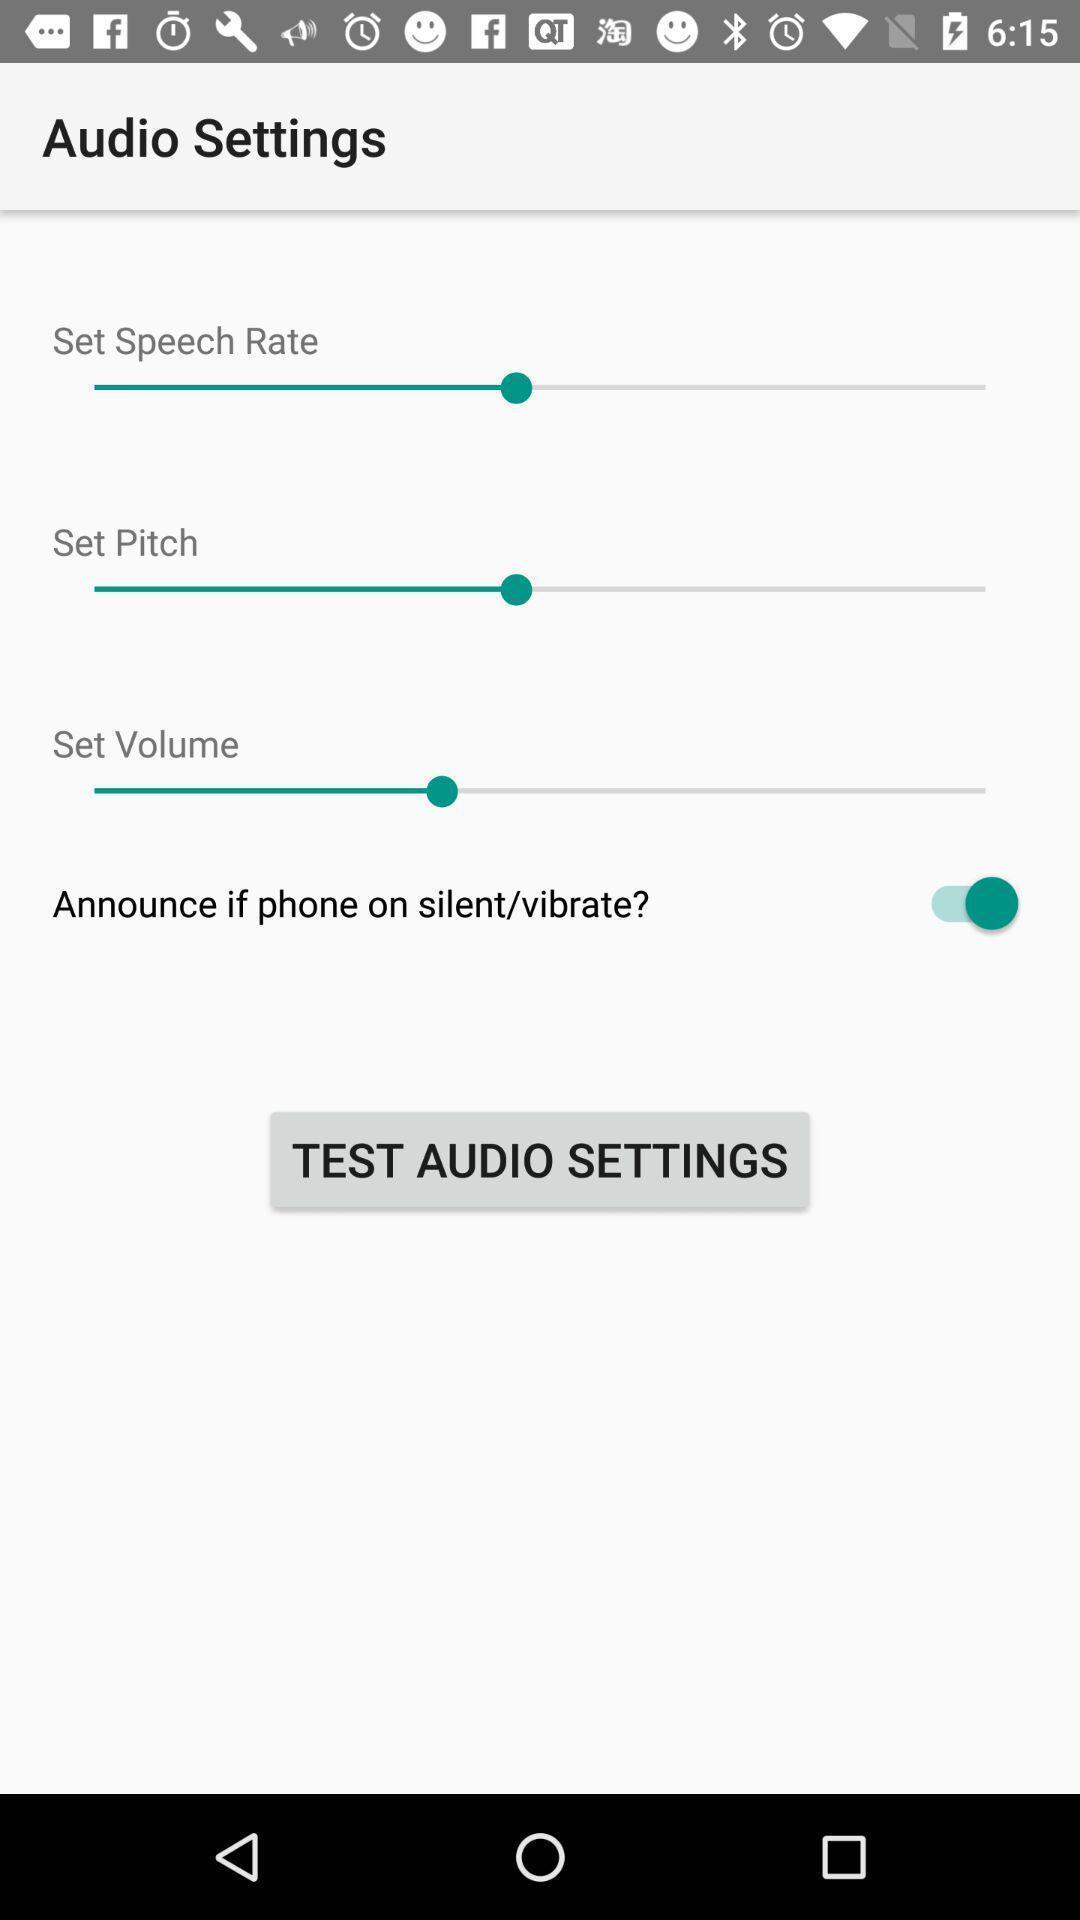Tell me about the visual elements in this screen capture. Page displaying with list of different settings for audio. 